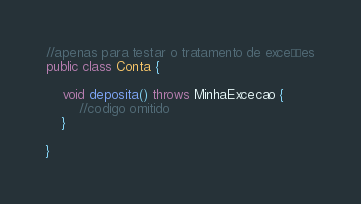Convert code to text. <code><loc_0><loc_0><loc_500><loc_500><_Java_>//apenas para testar o tratamento de exceções
public class Conta {

    void deposita() throws MinhaExcecao {
        //codigo omitido
    }

}</code> 